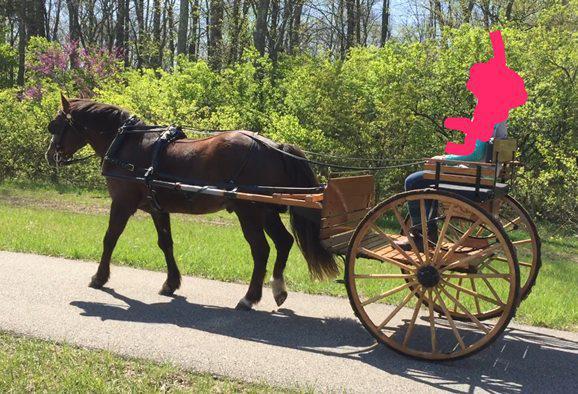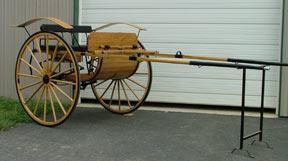The first image is the image on the left, the second image is the image on the right. Examine the images to the left and right. Is the description "One image shows an empty cart parked in front of a garage door." accurate? Answer yes or no. Yes. The first image is the image on the left, the second image is the image on the right. For the images displayed, is the sentence "there is a black horse in the image on the right" factually correct? Answer yes or no. No. 